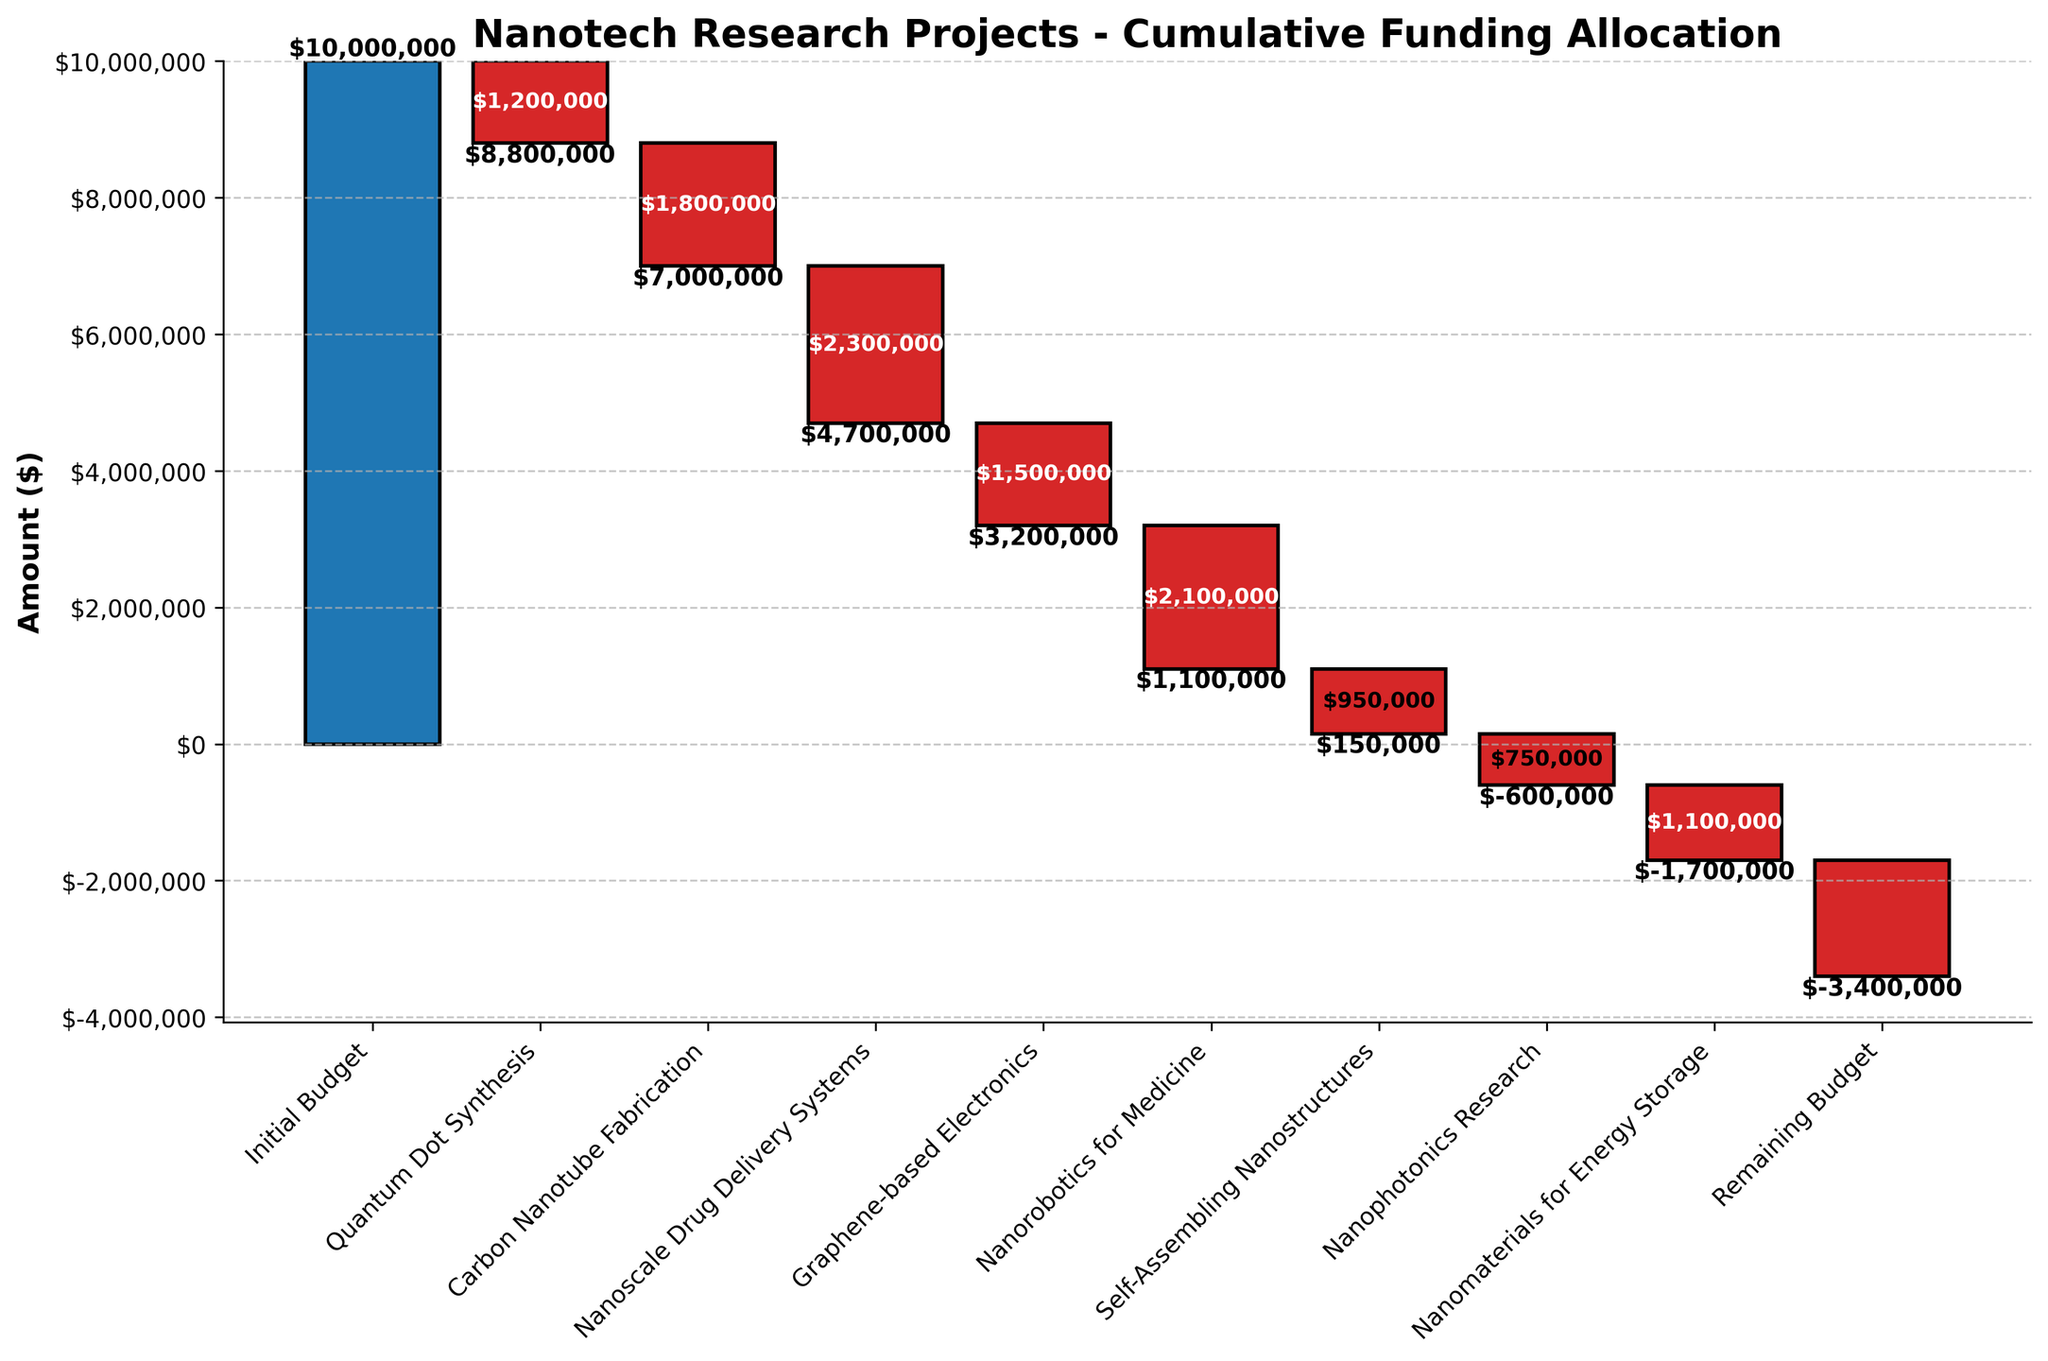What is the initial budget for the nanotech research projects? The initial budget is indicated by the first bar labeled "Initial Budget." The figure shows that this value is $10,000,000.
Answer: $10,000,000 What is the cumulative amount allocated to Quantum Dot Synthesis and Carbon Nanotube Fabrication? Add the amounts for Quantum Dot Synthesis and Carbon Nanotube Fabrication: -$1,200,000 and -$1,800,000, respectively. The total cumulative allocation is -$3,000,000.
Answer: -$3,000,000 Which project has the smallest amount allocated to it? By comparing the lengths of the bars, Nanophotonics Research has the smallest allocation with -$750,000.
Answer: Nanophotonics Research How much budget remains after funding all projects? The remaining budget is shown by the last bar labeled "Remaining Budget." This value is -$1,700,000.
Answer: -$1,700,000 What is the cumulative funding amount after Nanorobotics for Medicine? Calculate the cumulative sum up to and including Nanorobotics for Medicine: $10,000,000 - $1,200,000 - $1,800,000 - $2,300,000 - $1,500,000 - $2,100,000 = $1,100,000.
Answer: $1,100,000 How does the allocation for Nanoscale Drug Delivery Systems compare to that for Graphene-based Electronics? The allocation for Nanoscale Drug Delivery Systems is -$2,300,000, whereas for Graphene-based Electronics, it is -$1,500,000, meaning the former is greater by $800,000.
Answer: -$2,300,000 is $800,000 greater What's the total amount allocated to all nanotech research projects combined? Add all negative allocations: -$1,200,000 - $1,800,000 - $2,300,000 - $1,500,000 - $2,100,000 - $950,000 - $750,000 - $1,100,000 = -$11,700,000.
Answer: -$11,700,000 How much was allocated to Self-Assembling Nanostructures? Look at the bar labeled "Self-Assembling Nanostructures"; the allocation is -$950,000.
Answer: -$950,000 